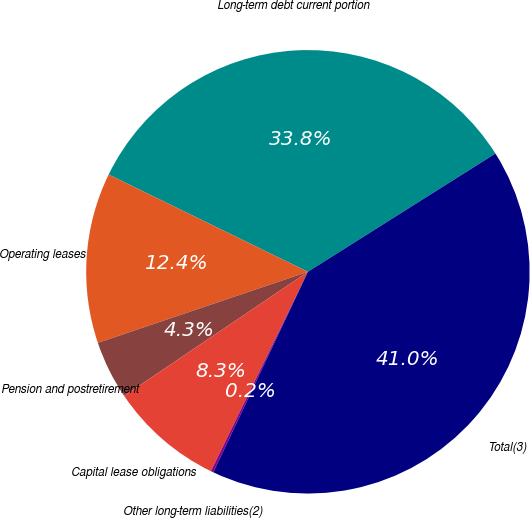Convert chart to OTSL. <chart><loc_0><loc_0><loc_500><loc_500><pie_chart><fcel>Long-term debt current portion<fcel>Operating leases<fcel>Pension and postretirement<fcel>Capital lease obligations<fcel>Other long-term liabilities(2)<fcel>Total(3)<nl><fcel>33.82%<fcel>12.42%<fcel>4.26%<fcel>8.34%<fcel>0.19%<fcel>40.97%<nl></chart> 